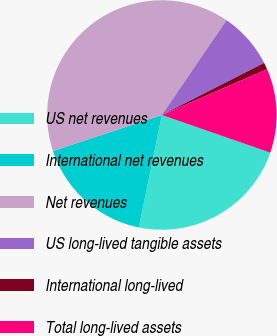<chart> <loc_0><loc_0><loc_500><loc_500><pie_chart><fcel>US net revenues<fcel>International net revenues<fcel>Net revenues<fcel>US long-lived tangible assets<fcel>International long-lived<fcel>Total long-lived assets<nl><fcel>22.88%<fcel>16.72%<fcel>39.6%<fcel>7.98%<fcel>0.97%<fcel>11.85%<nl></chart> 